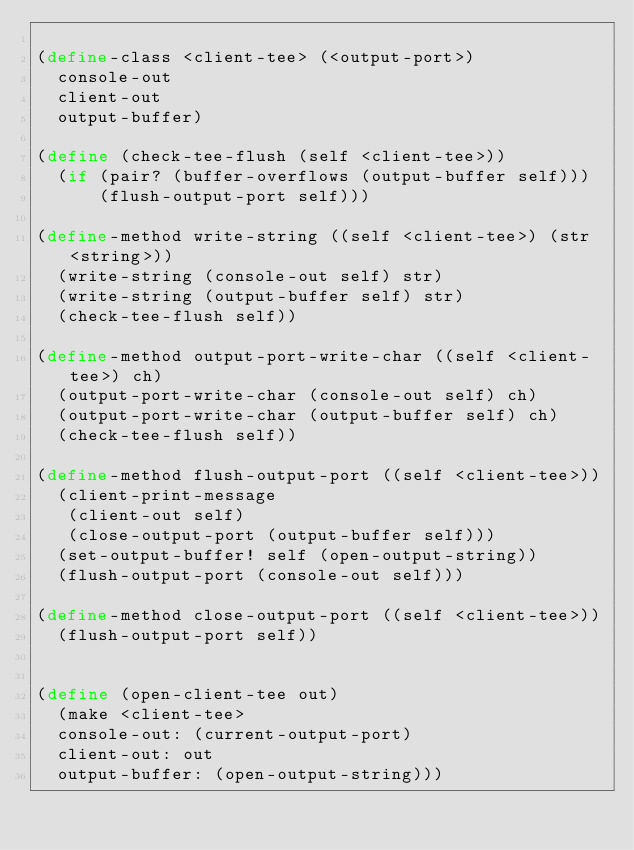<code> <loc_0><loc_0><loc_500><loc_500><_Scheme_>
(define-class <client-tee> (<output-port>)
  console-out
  client-out
  output-buffer)

(define (check-tee-flush (self <client-tee>))
  (if (pair? (buffer-overflows (output-buffer self)))
      (flush-output-port self)))

(define-method write-string ((self <client-tee>) (str <string>))
  (write-string (console-out self) str)
  (write-string (output-buffer self) str)
  (check-tee-flush self))

(define-method output-port-write-char ((self <client-tee>) ch)
  (output-port-write-char (console-out self) ch)
  (output-port-write-char (output-buffer self) ch)
  (check-tee-flush self))

(define-method flush-output-port ((self <client-tee>))
  (client-print-message 
   (client-out self)
   (close-output-port (output-buffer self)))
  (set-output-buffer! self (open-output-string))
  (flush-output-port (console-out self)))

(define-method close-output-port ((self <client-tee>))
  (flush-output-port self))

  
(define (open-client-tee out)
  (make <client-tee>
	console-out: (current-output-port)
	client-out: out
	output-buffer: (open-output-string)))
</code> 